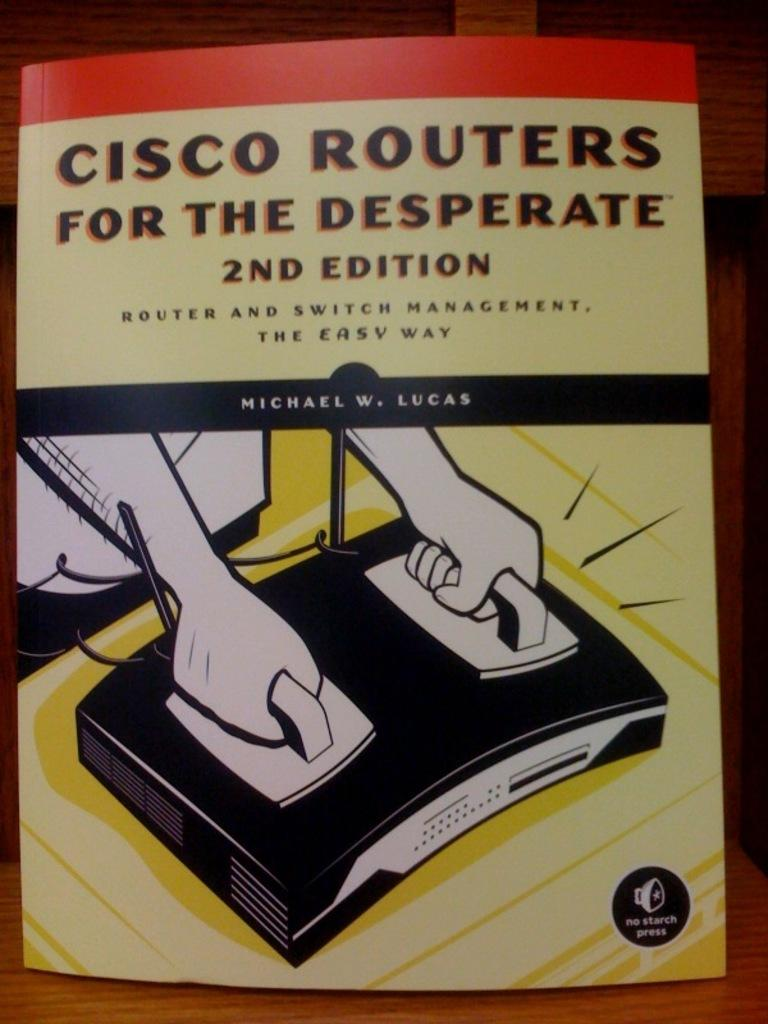<image>
Describe the image concisely. A computer reference book takes a humorous approach to routers and switch management. 